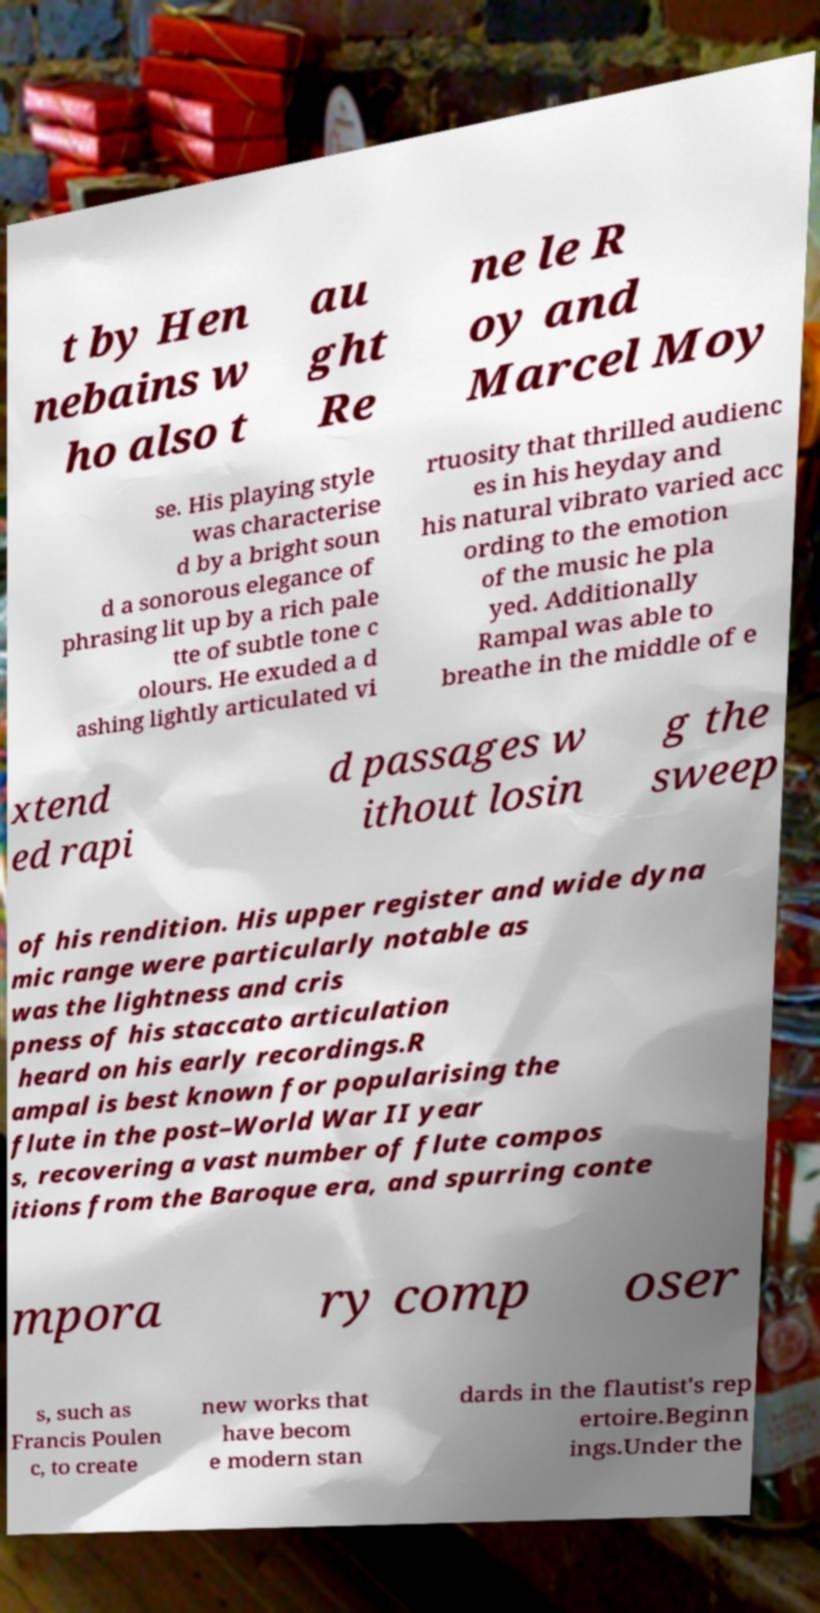For documentation purposes, I need the text within this image transcribed. Could you provide that? t by Hen nebains w ho also t au ght Re ne le R oy and Marcel Moy se. His playing style was characterise d by a bright soun d a sonorous elegance of phrasing lit up by a rich pale tte of subtle tone c olours. He exuded a d ashing lightly articulated vi rtuosity that thrilled audienc es in his heyday and his natural vibrato varied acc ording to the emotion of the music he pla yed. Additionally Rampal was able to breathe in the middle of e xtend ed rapi d passages w ithout losin g the sweep of his rendition. His upper register and wide dyna mic range were particularly notable as was the lightness and cris pness of his staccato articulation heard on his early recordings.R ampal is best known for popularising the flute in the post–World War II year s, recovering a vast number of flute compos itions from the Baroque era, and spurring conte mpora ry comp oser s, such as Francis Poulen c, to create new works that have becom e modern stan dards in the flautist's rep ertoire.Beginn ings.Under the 